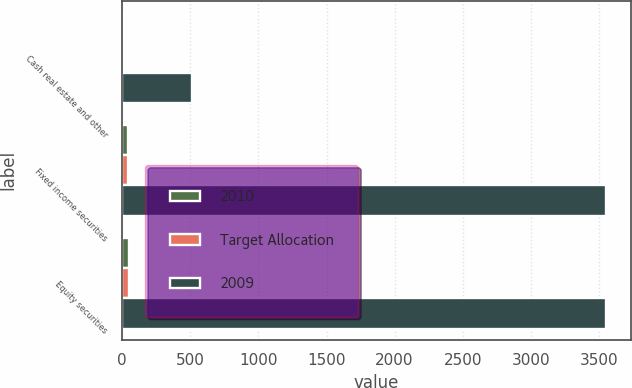Convert chart to OTSL. <chart><loc_0><loc_0><loc_500><loc_500><stacked_bar_chart><ecel><fcel>Cash real estate and other<fcel>Fixed income securities<fcel>Equity securities<nl><fcel>2010<fcel>11<fcel>40<fcel>49<nl><fcel>Target Allocation<fcel>9<fcel>45<fcel>46<nl><fcel>2009<fcel>515<fcel>3555<fcel>3555<nl></chart> 